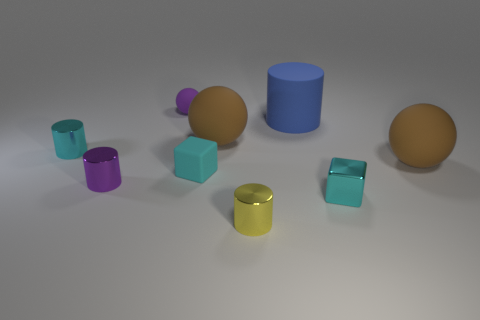Subtract all matte cylinders. How many cylinders are left? 3 Subtract all brown blocks. How many brown spheres are left? 2 Subtract all brown spheres. How many spheres are left? 1 Subtract 0 red cubes. How many objects are left? 9 Subtract all cubes. How many objects are left? 7 Subtract 1 cylinders. How many cylinders are left? 3 Subtract all gray cylinders. Subtract all brown blocks. How many cylinders are left? 4 Subtract all tiny brown metal cylinders. Subtract all rubber balls. How many objects are left? 6 Add 2 metal blocks. How many metal blocks are left? 3 Add 4 small matte objects. How many small matte objects exist? 6 